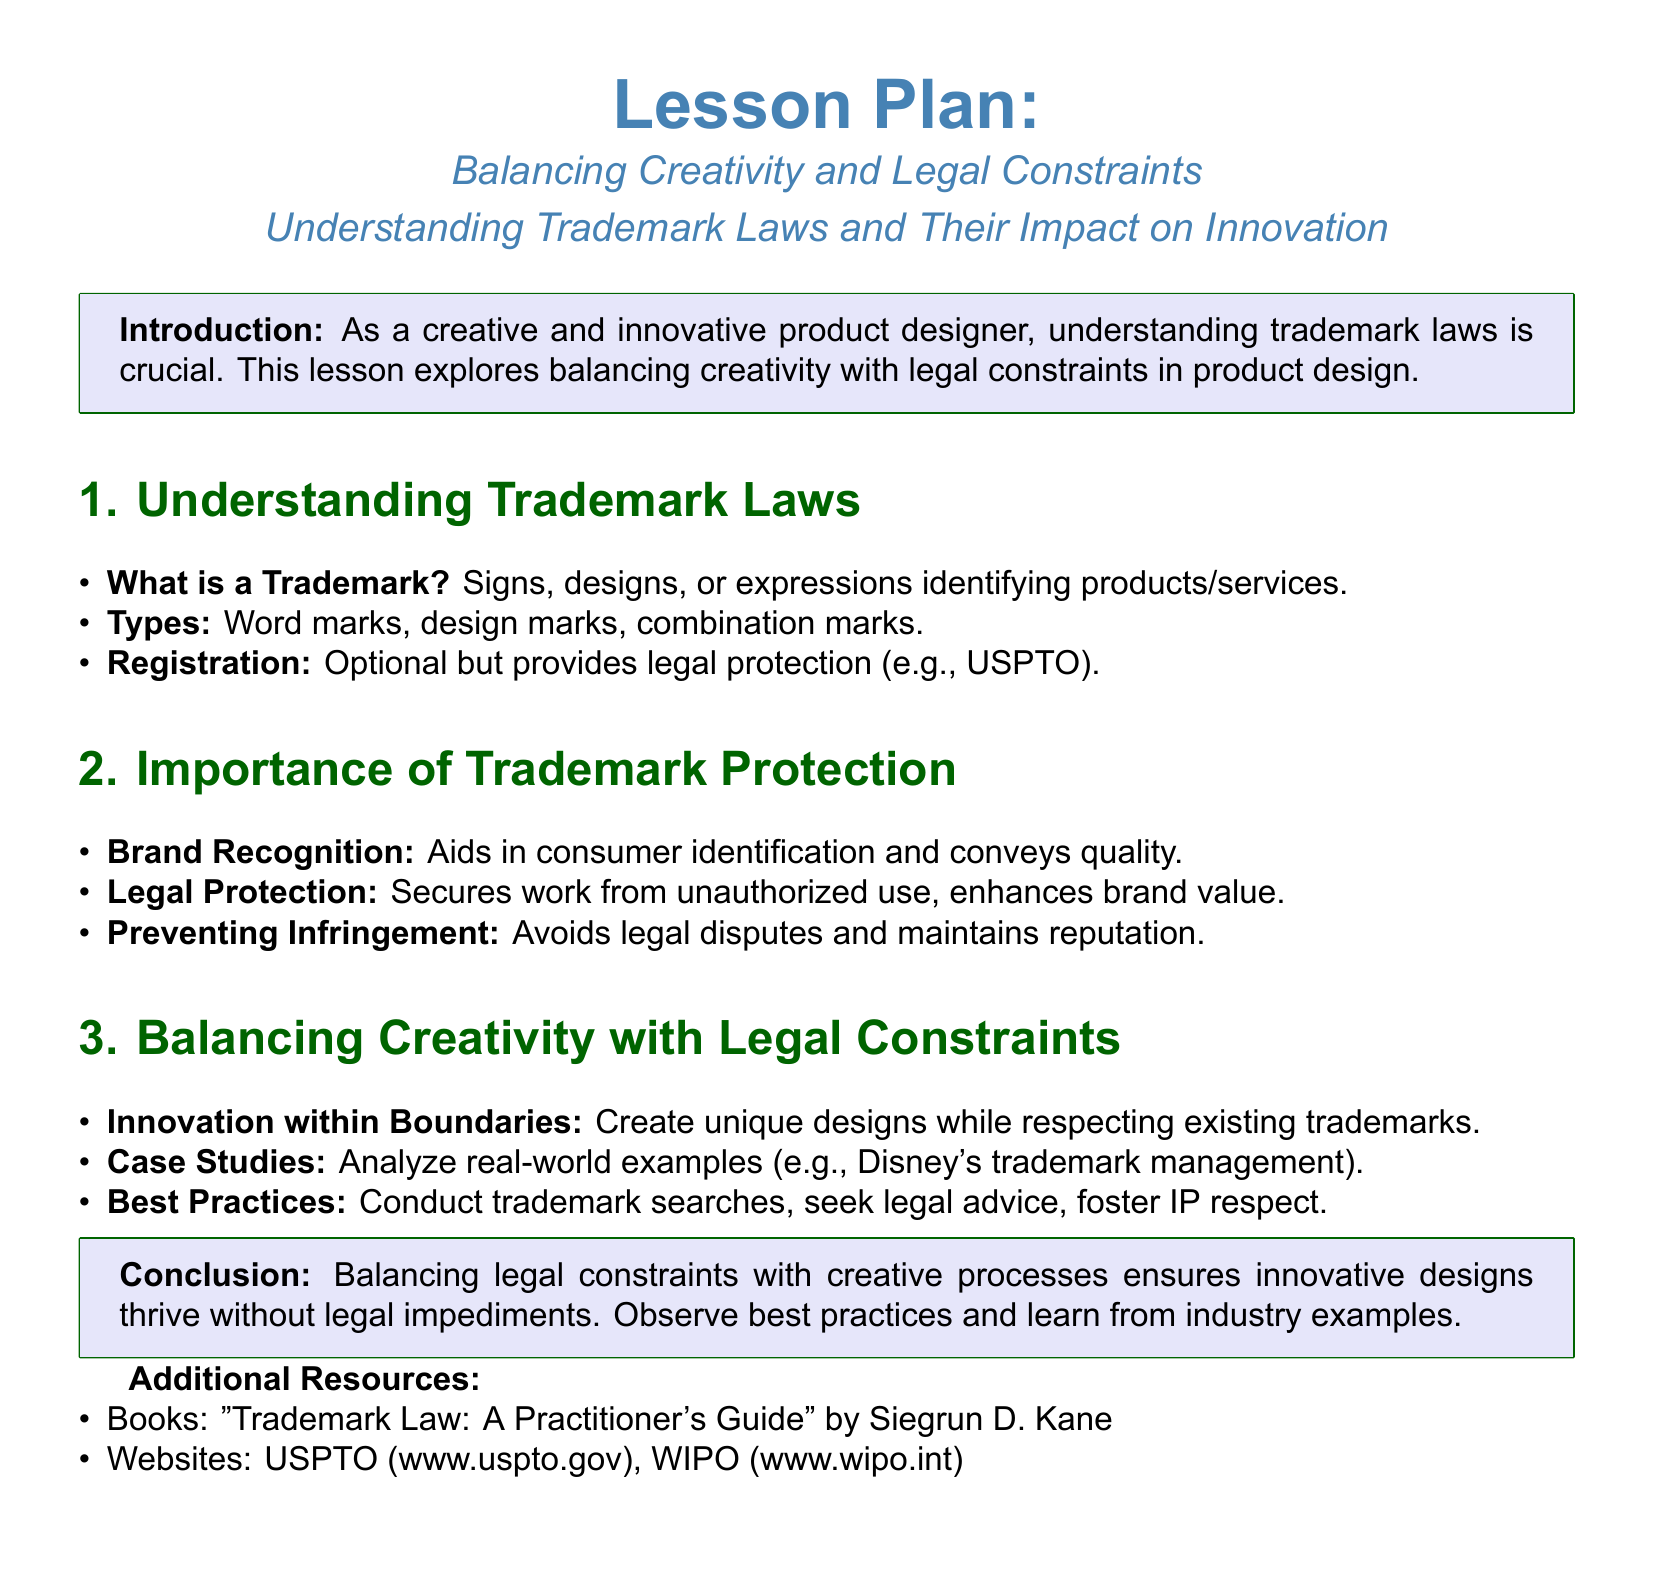What is a trademark? A trademark is a sign, design, or expression identifying products or services.
Answer: sign, design, or expression What are the types of trademarks mentioned? The document lists the types of trademarks as word marks, design marks, and combination marks.
Answer: word marks, design marks, combination marks What is optional for trademark protection? The registration of a trademark is optional but provides legal protection.
Answer: registration What is the purpose of trademark protection according to the lesson plan? Trademark protection is important for brand recognition, legal protection, and preventing infringement.
Answer: brand recognition, legal protection, preventing infringement How can innovation occur within legal boundaries? The lesson plan suggests creating unique designs while respecting existing trademarks.
Answer: unique designs while respecting existing trademarks Which case study is mentioned in the lesson plan? The lesson plan refers to Disney's trademark management as a case study.
Answer: Disney's trademark management What is recommended before designing products? Conducting trademark searches is recommended as a best practice before designing products.
Answer: conducting trademark searches What type of resources are suggested for further learning? The lesson plan suggests books and websites as additional resources.
Answer: books and websites 